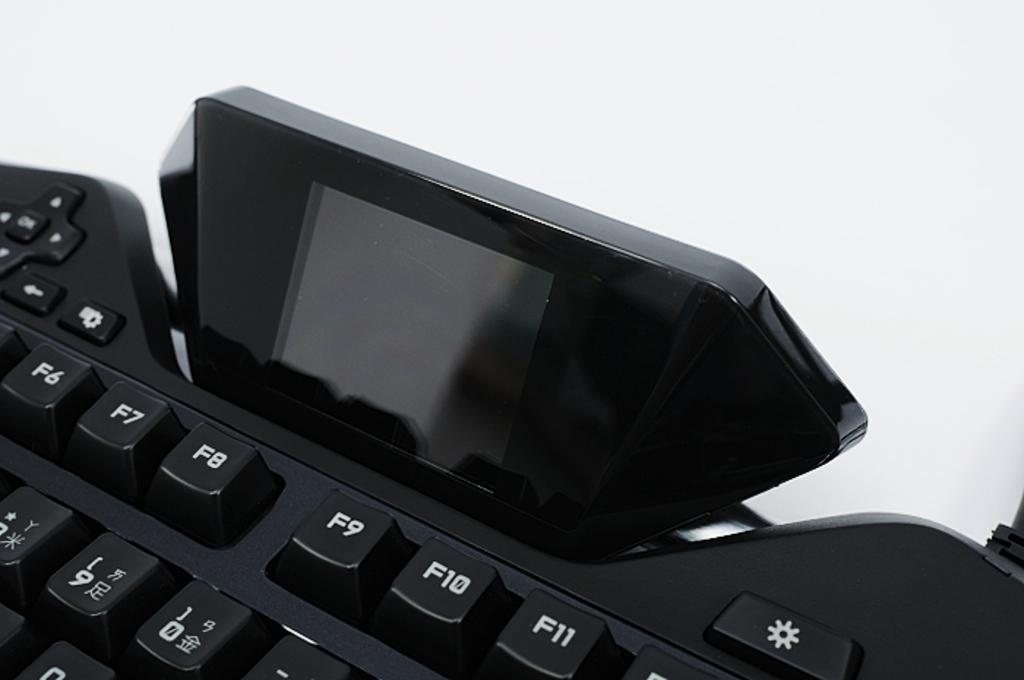<image>
Give a short and clear explanation of the subsequent image. a keyboard with the F row visible and japanese characters below it. 